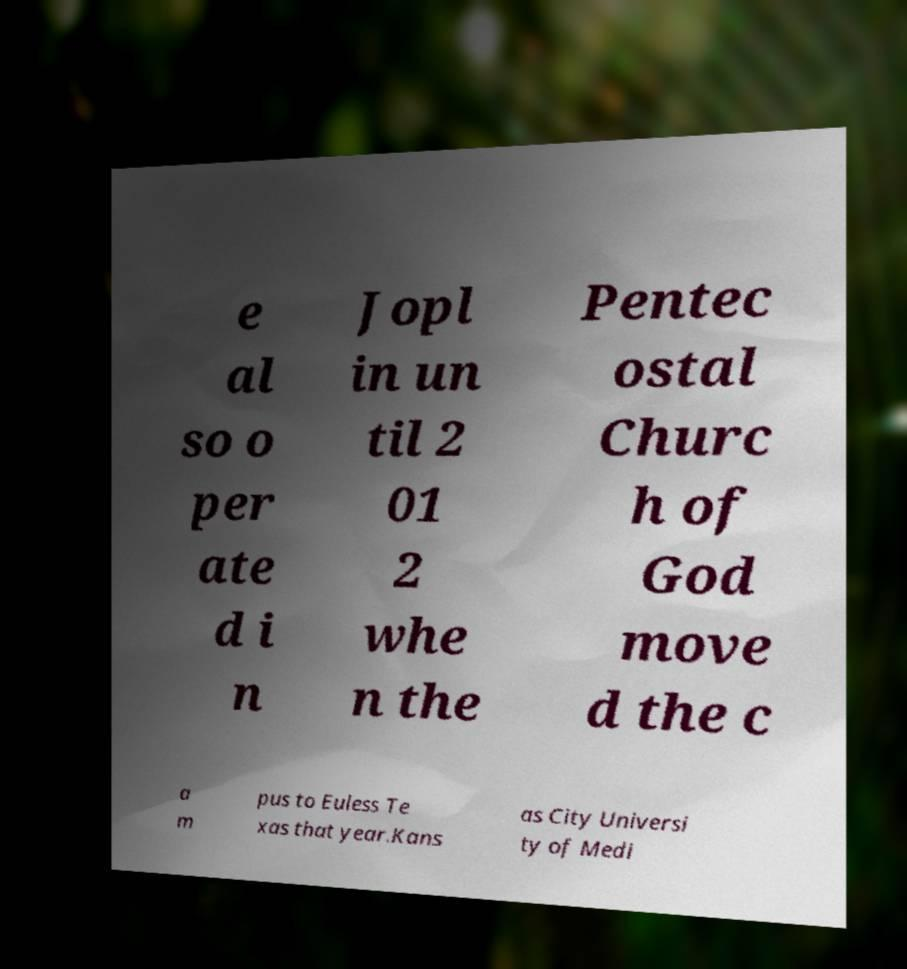Can you accurately transcribe the text from the provided image for me? e al so o per ate d i n Jopl in un til 2 01 2 whe n the Pentec ostal Churc h of God move d the c a m pus to Euless Te xas that year.Kans as City Universi ty of Medi 